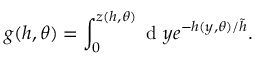<formula> <loc_0><loc_0><loc_500><loc_500>g ( h , \theta ) = \int _ { 0 } ^ { z ( h , \theta ) } d y e ^ { - h ( y , \theta ) / \tilde { h } } .</formula> 